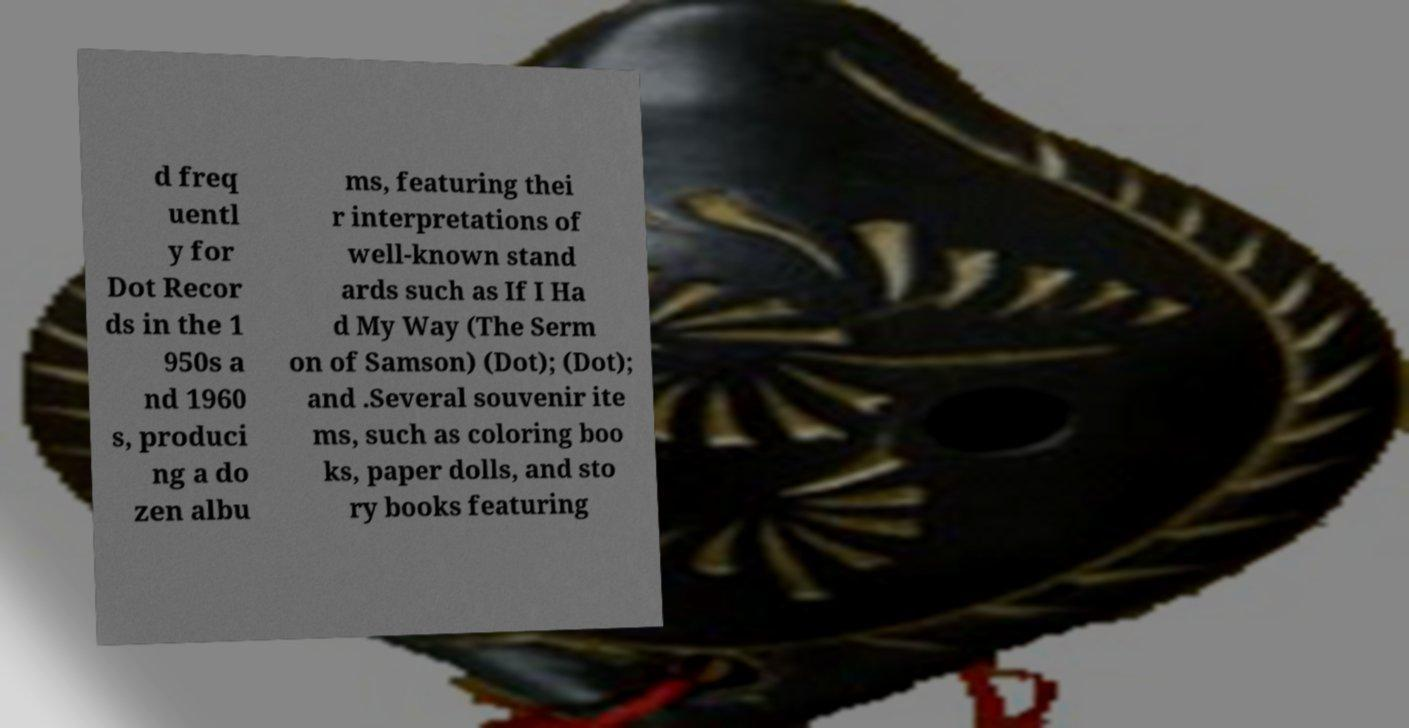Could you extract and type out the text from this image? d freq uentl y for Dot Recor ds in the 1 950s a nd 1960 s, produci ng a do zen albu ms, featuring thei r interpretations of well-known stand ards such as If I Ha d My Way (The Serm on of Samson) (Dot); (Dot); and .Several souvenir ite ms, such as coloring boo ks, paper dolls, and sto ry books featuring 